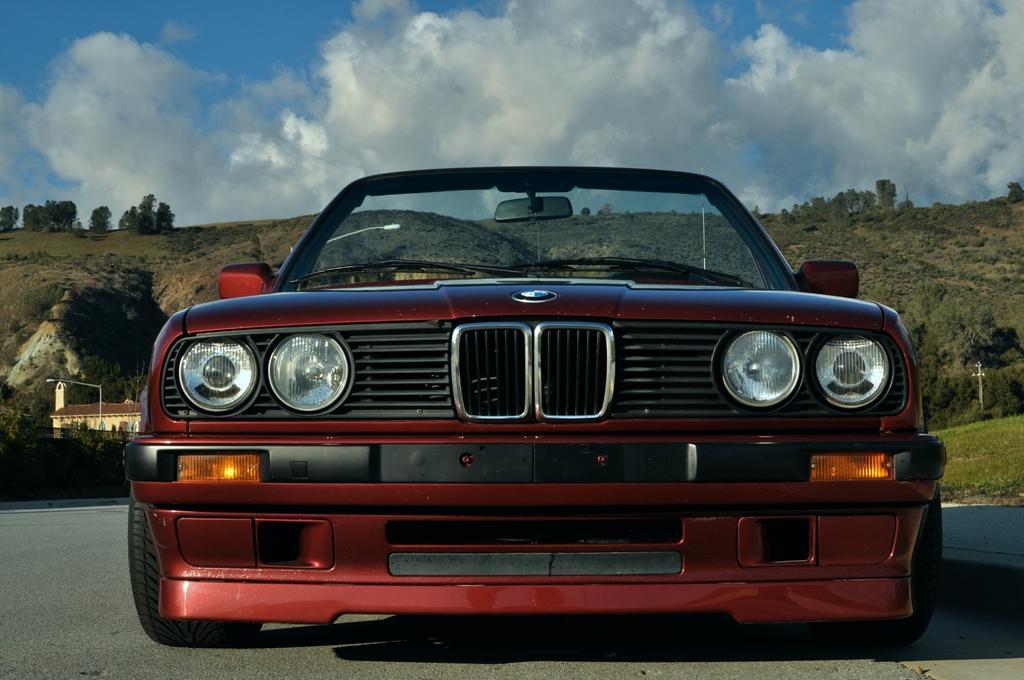Can you describe this image briefly? In this image I see a car which is of maroon in color and I see a logo over here and I see the road. In the background I see the grass and I see a house over here and I can also see few poles and I see the hills on which there are trees and I see the sky which is of white and blue in color. 